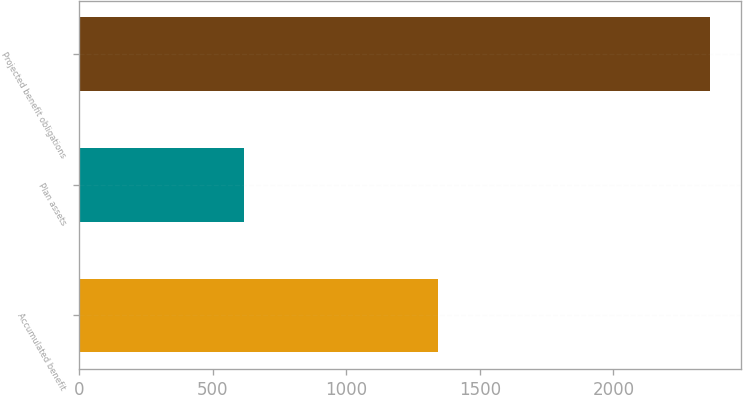Convert chart to OTSL. <chart><loc_0><loc_0><loc_500><loc_500><bar_chart><fcel>Accumulated benefit<fcel>Plan assets<fcel>Projected benefit obligations<nl><fcel>1344<fcel>616<fcel>2361<nl></chart> 